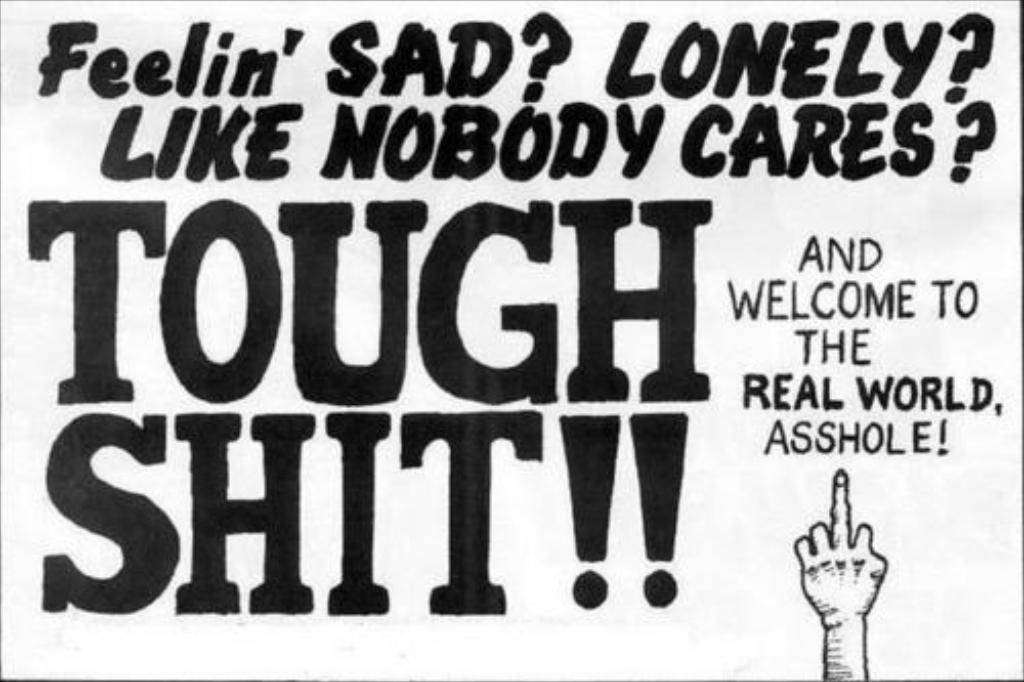Could you give a brief overview of what you see in this image? In the image there is some text and there is a hand at the bottom right side of the image. 